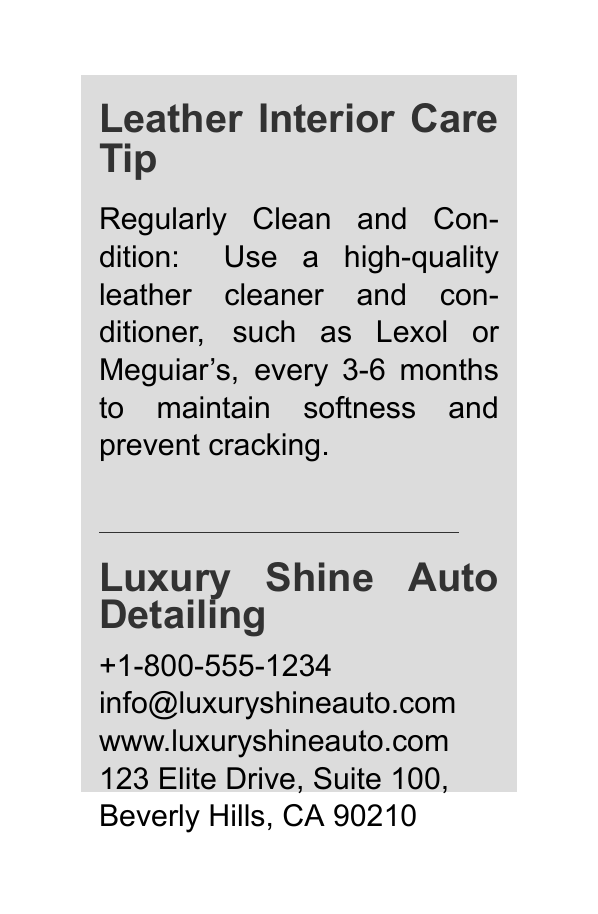What is the main care tip for leather interiors? The main care tip is about regularly cleaning and conditioning the leather.
Answer: Regularly Clean and Condition What products are recommended for leather care? The document specifically mentions using high-quality leather cleaner and conditioners like Lexol or Meguiar's.
Answer: Lexol or Meguiar's How often should leather be cleaned and conditioned? The tip states that this should be done every 3-6 months.
Answer: Every 3-6 months What is the name of the detailing company? The company providing the tip is named Luxury Shine Auto Detailing.
Answer: Luxury Shine Auto Detailing What is the phone number listed on the card? The phone number provided for the company is +1-800-555-1234.
Answer: +1-800-555-1234 What is the purpose of including contact information? It allows potential customers to reach out for services, which is essential for a business card.
Answer: To reach out for services What color is used for the background of the card? The background color of the card is white.
Answer: White What section typically follows the main care tip? The next section is for the company name and contact information.
Answer: Company name and contact information What type of document is this? The document is a business card, specifically for car detailing services.
Answer: Business card 